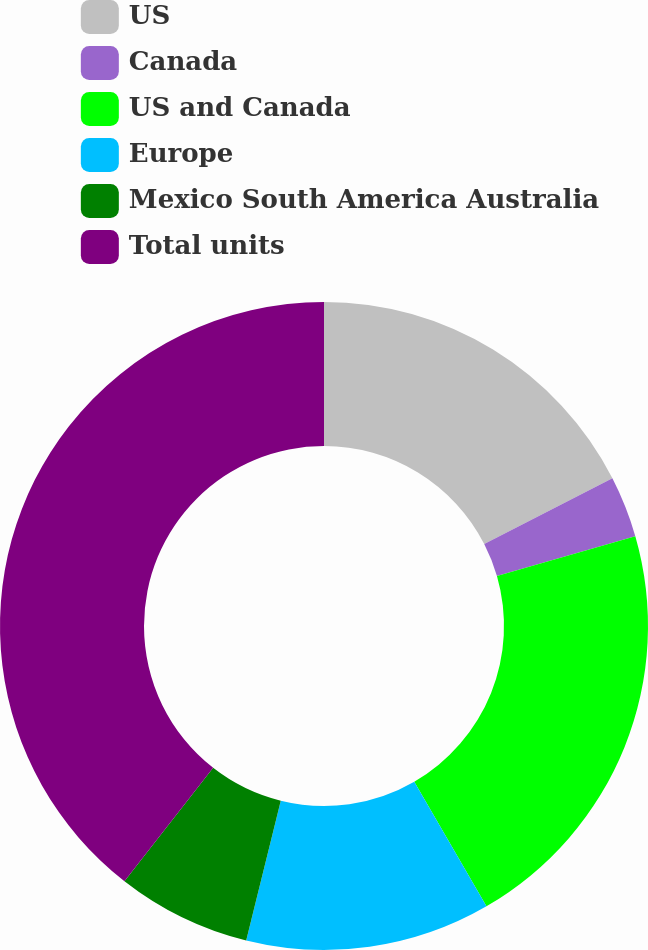Convert chart. <chart><loc_0><loc_0><loc_500><loc_500><pie_chart><fcel>US<fcel>Canada<fcel>US and Canada<fcel>Europe<fcel>Mexico South America Australia<fcel>Total units<nl><fcel>17.47%<fcel>3.06%<fcel>21.11%<fcel>12.22%<fcel>6.7%<fcel>39.44%<nl></chart> 